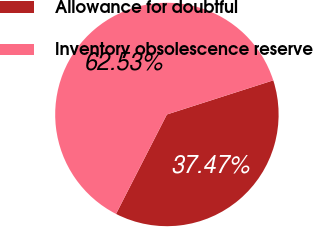Convert chart to OTSL. <chart><loc_0><loc_0><loc_500><loc_500><pie_chart><fcel>Allowance for doubtful<fcel>Inventory obsolescence reserve<nl><fcel>37.47%<fcel>62.53%<nl></chart> 